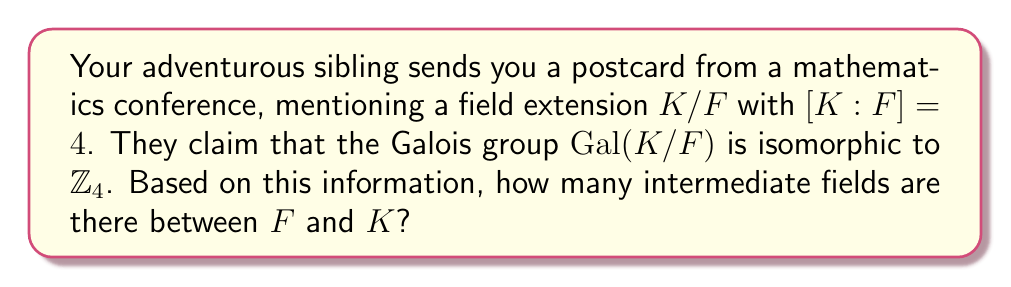Could you help me with this problem? Let's approach this step-by-step:

1) First, recall the Fundamental Theorem of Galois Theory: There is a one-to-one correspondence between intermediate fields of a Galois extension and subgroups of its Galois group.

2) We're told that $Gal(K/F) \cong \mathbb{Z}_4$, the cyclic group of order 4.

3) To find the number of intermediate fields, we need to count the number of subgroups of $\mathbb{Z}_4$.

4) The subgroups of $\mathbb{Z}_4$ are:
   - $\{0\}$ (the trivial subgroup)
   - $\{0,2\}$ (the subgroup of order 2)
   - $\mathbb{Z}_4$ itself (the whole group)

5) Therefore, $\mathbb{Z}_4$ has 3 subgroups.

6) By the Fundamental Theorem of Galois Theory, each of these subgroups corresponds to an intermediate field:
   - $\{0\}$ corresponds to $K$
   - $\{0,2\}$ corresponds to an intermediate field $L$ such that $[K:L] = 2$ and $[L:F] = 2$
   - $\mathbb{Z}_4$ corresponds to $F$

7) Thus, there are 3 fields in total: $F$, $K$, and one intermediate field $L$.

8) The number of intermediate fields (excluding $F$ and $K$) is 1.
Answer: 1 